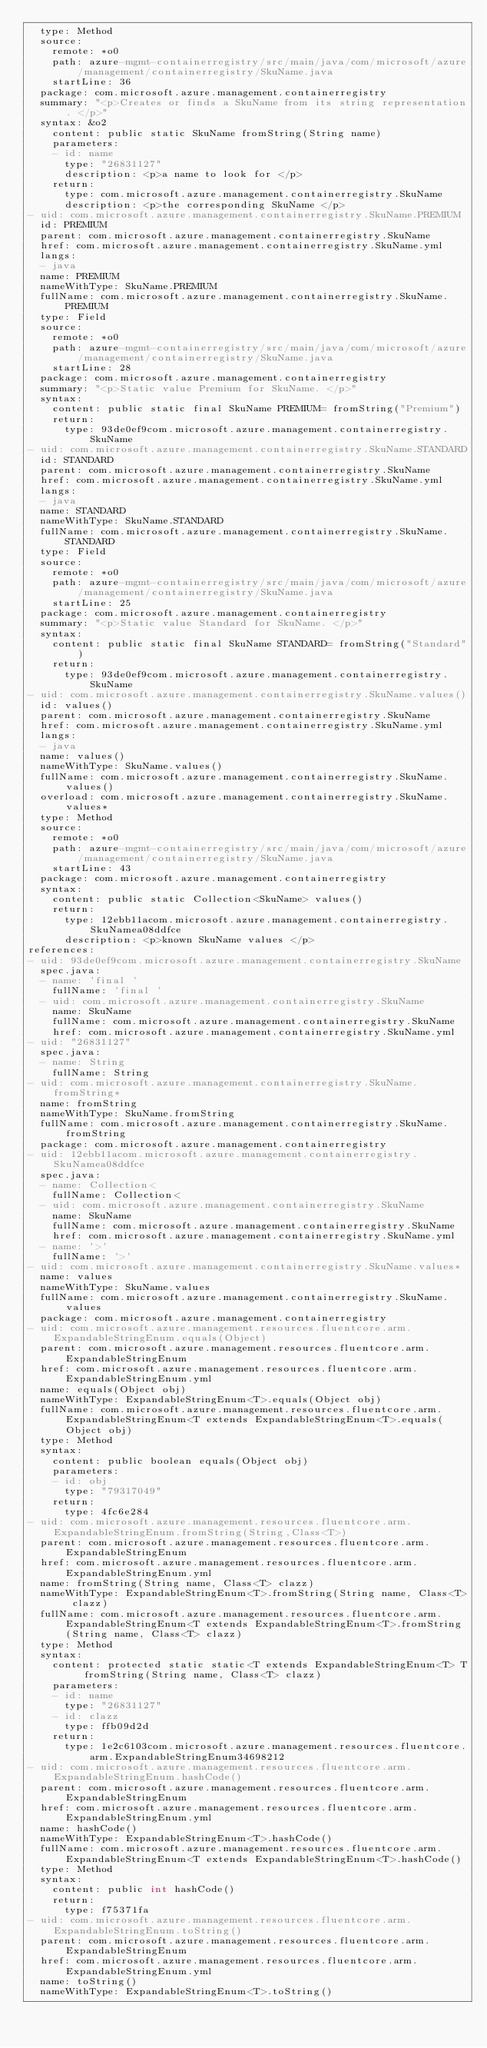<code> <loc_0><loc_0><loc_500><loc_500><_YAML_>  type: Method
  source:
    remote: *o0
    path: azure-mgmt-containerregistry/src/main/java/com/microsoft/azure/management/containerregistry/SkuName.java
    startLine: 36
  package: com.microsoft.azure.management.containerregistry
  summary: "<p>Creates or finds a SkuName from its string representation. </p>"
  syntax: &o2
    content: public static SkuName fromString(String name)
    parameters:
    - id: name
      type: "26831127"
      description: <p>a name to look for </p>
    return:
      type: com.microsoft.azure.management.containerregistry.SkuName
      description: <p>the corresponding SkuName </p>
- uid: com.microsoft.azure.management.containerregistry.SkuName.PREMIUM
  id: PREMIUM
  parent: com.microsoft.azure.management.containerregistry.SkuName
  href: com.microsoft.azure.management.containerregistry.SkuName.yml
  langs:
  - java
  name: PREMIUM
  nameWithType: SkuName.PREMIUM
  fullName: com.microsoft.azure.management.containerregistry.SkuName.PREMIUM
  type: Field
  source:
    remote: *o0
    path: azure-mgmt-containerregistry/src/main/java/com/microsoft/azure/management/containerregistry/SkuName.java
    startLine: 28
  package: com.microsoft.azure.management.containerregistry
  summary: "<p>Static value Premium for SkuName. </p>"
  syntax:
    content: public static final SkuName PREMIUM= fromString("Premium")
    return:
      type: 93de0ef9com.microsoft.azure.management.containerregistry.SkuName
- uid: com.microsoft.azure.management.containerregistry.SkuName.STANDARD
  id: STANDARD
  parent: com.microsoft.azure.management.containerregistry.SkuName
  href: com.microsoft.azure.management.containerregistry.SkuName.yml
  langs:
  - java
  name: STANDARD
  nameWithType: SkuName.STANDARD
  fullName: com.microsoft.azure.management.containerregistry.SkuName.STANDARD
  type: Field
  source:
    remote: *o0
    path: azure-mgmt-containerregistry/src/main/java/com/microsoft/azure/management/containerregistry/SkuName.java
    startLine: 25
  package: com.microsoft.azure.management.containerregistry
  summary: "<p>Static value Standard for SkuName. </p>"
  syntax:
    content: public static final SkuName STANDARD= fromString("Standard")
    return:
      type: 93de0ef9com.microsoft.azure.management.containerregistry.SkuName
- uid: com.microsoft.azure.management.containerregistry.SkuName.values()
  id: values()
  parent: com.microsoft.azure.management.containerregistry.SkuName
  href: com.microsoft.azure.management.containerregistry.SkuName.yml
  langs:
  - java
  name: values()
  nameWithType: SkuName.values()
  fullName: com.microsoft.azure.management.containerregistry.SkuName.values()
  overload: com.microsoft.azure.management.containerregistry.SkuName.values*
  type: Method
  source:
    remote: *o0
    path: azure-mgmt-containerregistry/src/main/java/com/microsoft/azure/management/containerregistry/SkuName.java
    startLine: 43
  package: com.microsoft.azure.management.containerregistry
  syntax:
    content: public static Collection<SkuName> values()
    return:
      type: 12ebb11acom.microsoft.azure.management.containerregistry.SkuNamea08ddfce
      description: <p>known SkuName values </p>
references:
- uid: 93de0ef9com.microsoft.azure.management.containerregistry.SkuName
  spec.java:
  - name: 'final '
    fullName: 'final '
  - uid: com.microsoft.azure.management.containerregistry.SkuName
    name: SkuName
    fullName: com.microsoft.azure.management.containerregistry.SkuName
    href: com.microsoft.azure.management.containerregistry.SkuName.yml
- uid: "26831127"
  spec.java:
  - name: String
    fullName: String
- uid: com.microsoft.azure.management.containerregistry.SkuName.fromString*
  name: fromString
  nameWithType: SkuName.fromString
  fullName: com.microsoft.azure.management.containerregistry.SkuName.fromString
  package: com.microsoft.azure.management.containerregistry
- uid: 12ebb11acom.microsoft.azure.management.containerregistry.SkuNamea08ddfce
  spec.java:
  - name: Collection<
    fullName: Collection<
  - uid: com.microsoft.azure.management.containerregistry.SkuName
    name: SkuName
    fullName: com.microsoft.azure.management.containerregistry.SkuName
    href: com.microsoft.azure.management.containerregistry.SkuName.yml
  - name: '>'
    fullName: '>'
- uid: com.microsoft.azure.management.containerregistry.SkuName.values*
  name: values
  nameWithType: SkuName.values
  fullName: com.microsoft.azure.management.containerregistry.SkuName.values
  package: com.microsoft.azure.management.containerregistry
- uid: com.microsoft.azure.management.resources.fluentcore.arm.ExpandableStringEnum.equals(Object)
  parent: com.microsoft.azure.management.resources.fluentcore.arm.ExpandableStringEnum
  href: com.microsoft.azure.management.resources.fluentcore.arm.ExpandableStringEnum.yml
  name: equals(Object obj)
  nameWithType: ExpandableStringEnum<T>.equals(Object obj)
  fullName: com.microsoft.azure.management.resources.fluentcore.arm.ExpandableStringEnum<T extends ExpandableStringEnum<T>.equals(Object obj)
  type: Method
  syntax:
    content: public boolean equals(Object obj)
    parameters:
    - id: obj
      type: "79317049"
    return:
      type: 4fc6e284
- uid: com.microsoft.azure.management.resources.fluentcore.arm.ExpandableStringEnum.fromString(String,Class<T>)
  parent: com.microsoft.azure.management.resources.fluentcore.arm.ExpandableStringEnum
  href: com.microsoft.azure.management.resources.fluentcore.arm.ExpandableStringEnum.yml
  name: fromString(String name, Class<T> clazz)
  nameWithType: ExpandableStringEnum<T>.fromString(String name, Class<T> clazz)
  fullName: com.microsoft.azure.management.resources.fluentcore.arm.ExpandableStringEnum<T extends ExpandableStringEnum<T>.fromString(String name, Class<T> clazz)
  type: Method
  syntax:
    content: protected static static<T extends ExpandableStringEnum<T> T fromString(String name, Class<T> clazz)
    parameters:
    - id: name
      type: "26831127"
    - id: clazz
      type: ffb09d2d
    return:
      type: 1e2c6103com.microsoft.azure.management.resources.fluentcore.arm.ExpandableStringEnum34698212
- uid: com.microsoft.azure.management.resources.fluentcore.arm.ExpandableStringEnum.hashCode()
  parent: com.microsoft.azure.management.resources.fluentcore.arm.ExpandableStringEnum
  href: com.microsoft.azure.management.resources.fluentcore.arm.ExpandableStringEnum.yml
  name: hashCode()
  nameWithType: ExpandableStringEnum<T>.hashCode()
  fullName: com.microsoft.azure.management.resources.fluentcore.arm.ExpandableStringEnum<T extends ExpandableStringEnum<T>.hashCode()
  type: Method
  syntax:
    content: public int hashCode()
    return:
      type: f75371fa
- uid: com.microsoft.azure.management.resources.fluentcore.arm.ExpandableStringEnum.toString()
  parent: com.microsoft.azure.management.resources.fluentcore.arm.ExpandableStringEnum
  href: com.microsoft.azure.management.resources.fluentcore.arm.ExpandableStringEnum.yml
  name: toString()
  nameWithType: ExpandableStringEnum<T>.toString()</code> 